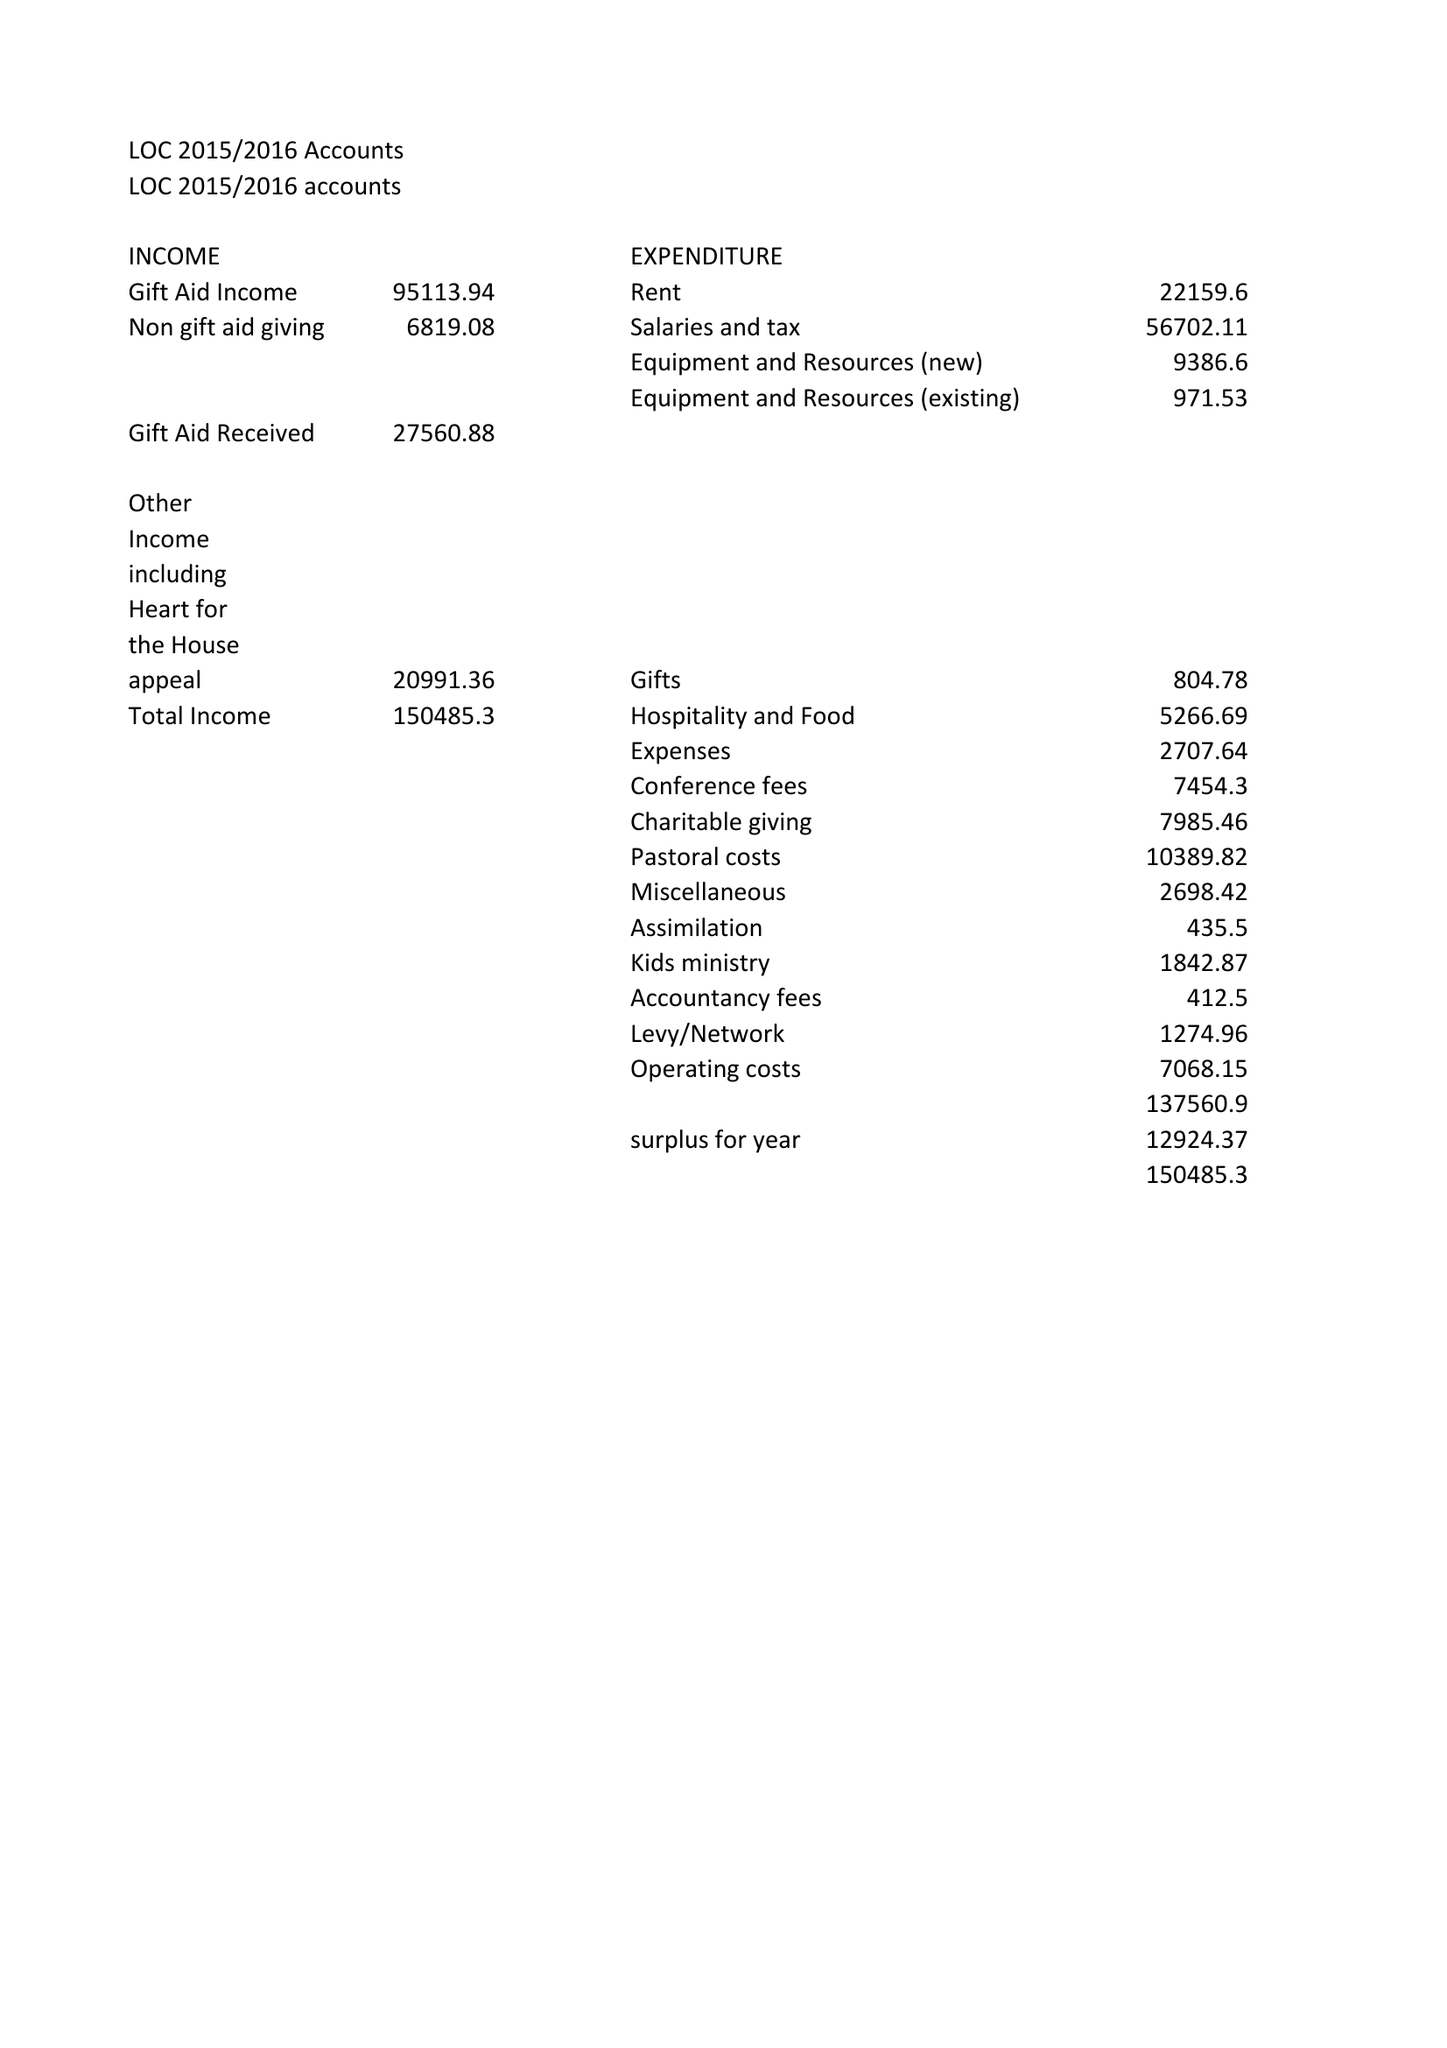What is the value for the address__postcode?
Answer the question using a single word or phrase. None 